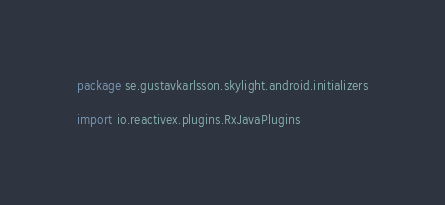Convert code to text. <code><loc_0><loc_0><loc_500><loc_500><_Kotlin_>package se.gustavkarlsson.skylight.android.initializers

import io.reactivex.plugins.RxJavaPlugins</code> 